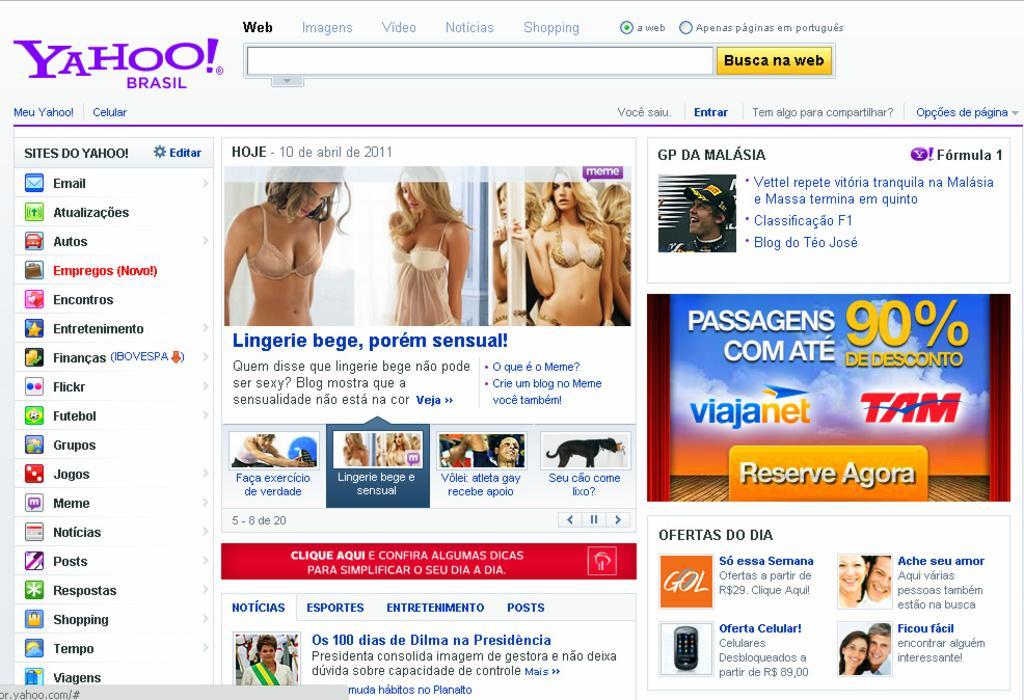Can you describe this image briefly? In the picture I can see a web page. In the web page I can see photos of people, logos and some text written on the page. 